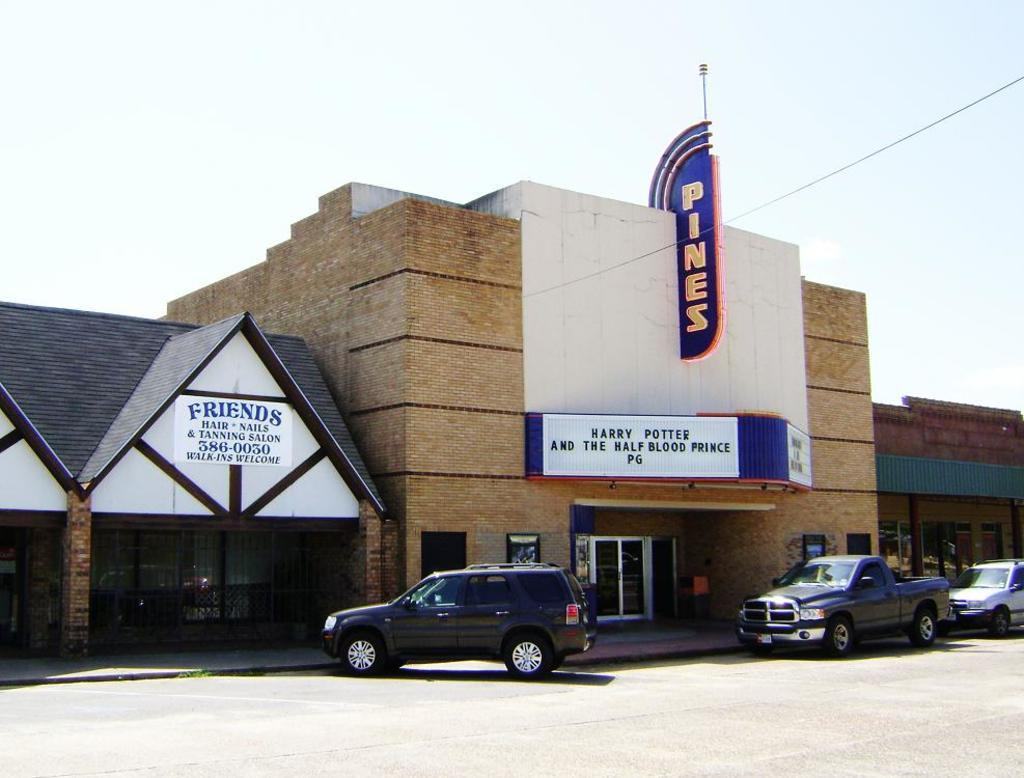What type of structure is present in the image? There is a building in the image. What is written or displayed on the building? There are boards with text on the building. What is located at the bottom of the image? There is a road at the bottom of the image. How many cars are parked on the road? Three cars are parked on the road. What can be seen at the top of the image? There is a sky visible at the top of the image. What type of liquid is being poured by the sister in the image? There is no sister or liquid present in the image. 